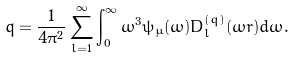<formula> <loc_0><loc_0><loc_500><loc_500>q = \frac { 1 } { 4 \pi ^ { 2 } } \sum _ { l = 1 } ^ { \infty } \int _ { 0 } ^ { \infty } { \omega ^ { 3 } \psi _ { \mu } ( \omega ) D _ { l } ^ { ( q ) } ( \omega r ) d \omega } .</formula> 